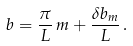Convert formula to latex. <formula><loc_0><loc_0><loc_500><loc_500>b = \frac { \pi } { L } \, m + \frac { \delta b _ { m } } { L } \, .</formula> 